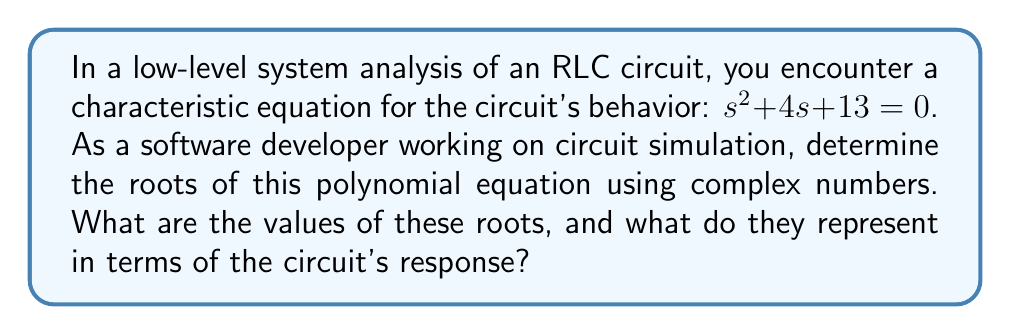Teach me how to tackle this problem. To solve this problem, we'll follow these steps:

1) The characteristic equation is in the form of a quadratic equation:
   $as^2 + bs + c = 0$
   where $a = 1$, $b = 4$, and $c = 13$

2) We can use the quadratic formula to find the roots:
   $s = \frac{-b \pm \sqrt{b^2 - 4ac}}{2a}$

3) Substituting our values:
   $s = \frac{-4 \pm \sqrt{4^2 - 4(1)(13)}}{2(1)}$
   $= \frac{-4 \pm \sqrt{16 - 52}}{2}$
   $= \frac{-4 \pm \sqrt{-36}}{2}$

4) Simplify under the square root:
   $= \frac{-4 \pm 6i}{2}$

5) Separate the real and imaginary parts:
   $= -2 \pm 3i$

6) Therefore, the two roots are:
   $s_1 = -2 + 3i$
   $s_2 = -2 - 3i$

These complex roots represent the natural response of the circuit. In the context of circuit analysis:

- The real part (-2) represents the damping factor of the circuit. A negative real part indicates that the circuit's response will decay over time.
- The imaginary part (±3i) represents the oscillation frequency of the circuit's response.

The presence of complex roots indicates that the circuit is underdamped, meaning it will oscillate with decreasing amplitude over time.
Answer: The roots of the characteristic equation are $s_1 = -2 + 3i$ and $s_2 = -2 - 3i$. These complex roots indicate an underdamped system with a damping factor of -2 and an oscillation frequency represented by ±3i. 